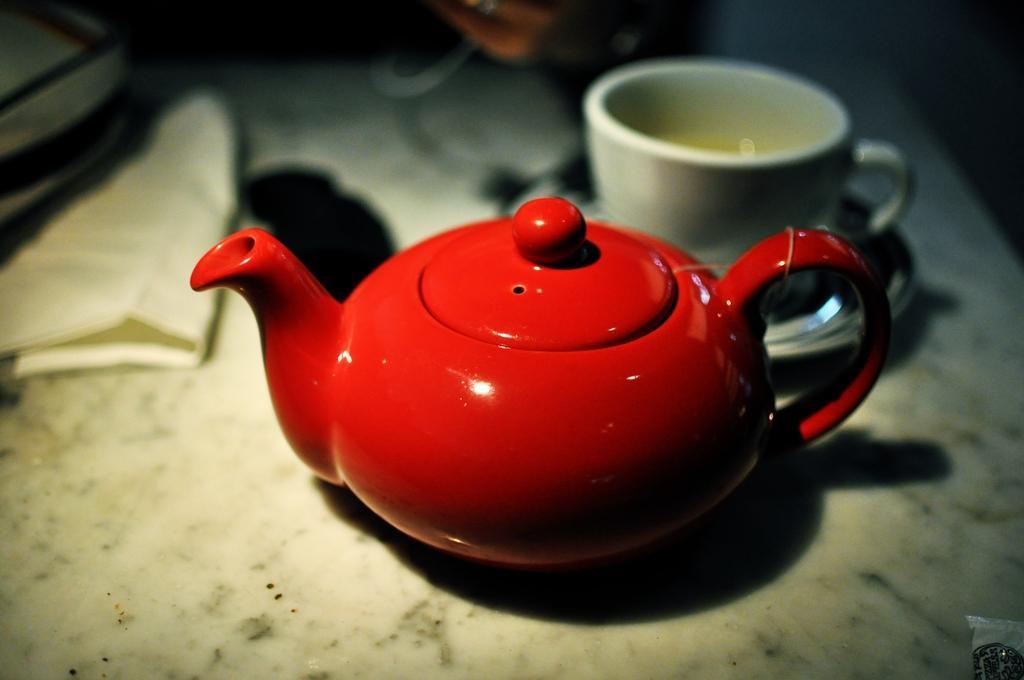In one or two sentences, can you explain what this image depicts? In this picture we can see kettle, cup and objects on the platform. In the background of the image it is blurry. 